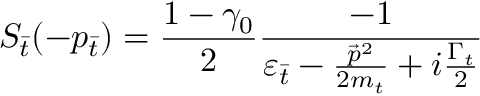<formula> <loc_0><loc_0><loc_500><loc_500>S _ { \bar { t } } ( - p _ { \bar { t } } ) = \frac { 1 - { \gamma } _ { 0 } } { 2 } \frac { - 1 } { { \varepsilon } _ { \bar { t } } - \frac { { \vec { p } } ^ { 2 } } { 2 m _ { t } } + i \frac { { \Gamma } _ { t } } { 2 } }</formula> 